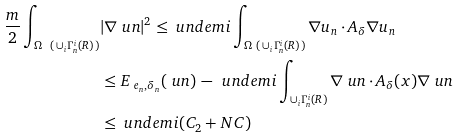<formula> <loc_0><loc_0><loc_500><loc_500>\frac { m } { 2 } \int _ { \Omega \ ( \, \cup _ { i } \Gamma _ { n } ^ { i } ( R ) \, ) } & | \nabla \ u n | ^ { 2 } \leq \ u n d e m i \int _ { \Omega \ ( \, \cup _ { i } \Gamma _ { n } ^ { i } ( R ) \, ) } \nabla u _ { n } \cdot A _ { \delta } \nabla u _ { n } \\ & \leq E _ { \ e _ { n } , \delta _ { n } } ( \ u n ) \, - \, \ u n d e m i \int _ { \cup _ { i } \Gamma _ { n } ^ { i } ( R ) } \nabla \ u n \cdot A _ { \delta } ( x ) \nabla \ u n \\ & \leq \ u n d e m i ( C _ { 2 } + N C )</formula> 